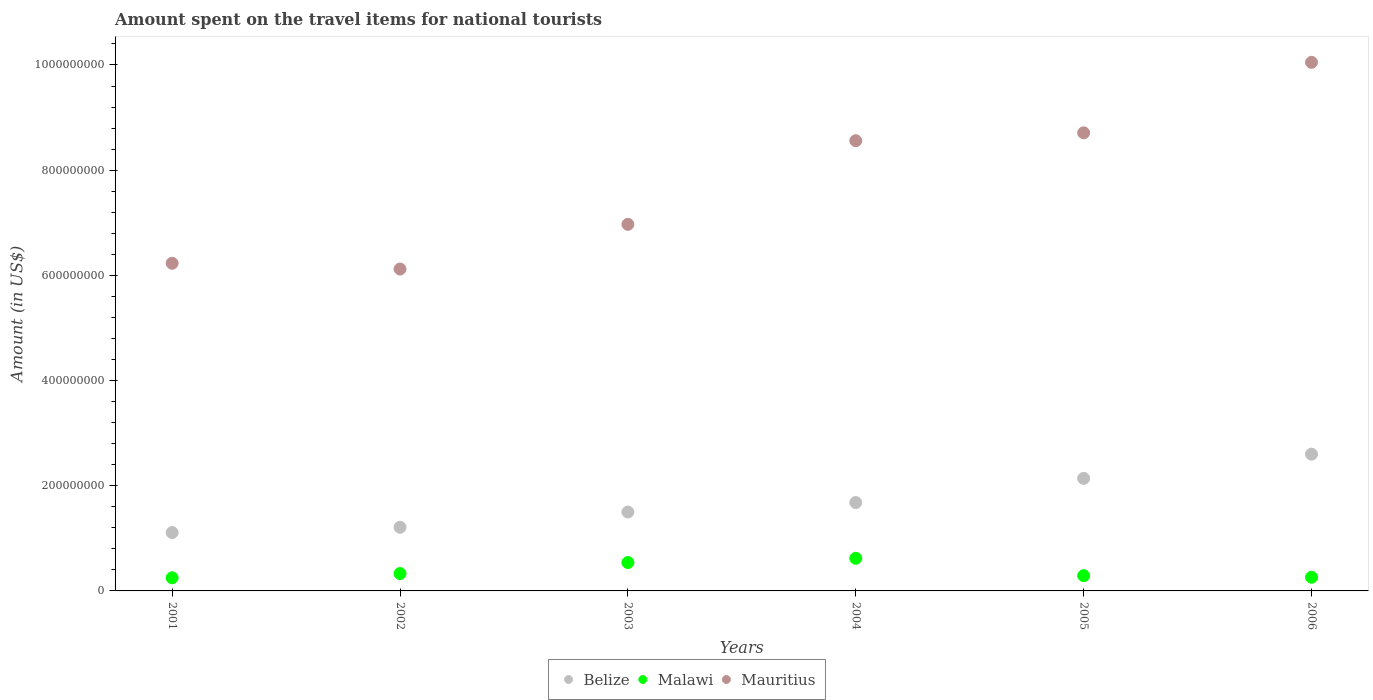Is the number of dotlines equal to the number of legend labels?
Your response must be concise. Yes. What is the amount spent on the travel items for national tourists in Mauritius in 2001?
Your answer should be compact. 6.23e+08. Across all years, what is the maximum amount spent on the travel items for national tourists in Mauritius?
Make the answer very short. 1.00e+09. Across all years, what is the minimum amount spent on the travel items for national tourists in Mauritius?
Your answer should be very brief. 6.12e+08. In which year was the amount spent on the travel items for national tourists in Mauritius maximum?
Offer a very short reply. 2006. What is the total amount spent on the travel items for national tourists in Mauritius in the graph?
Offer a terse response. 4.66e+09. What is the difference between the amount spent on the travel items for national tourists in Malawi in 2001 and that in 2003?
Your answer should be compact. -2.90e+07. What is the difference between the amount spent on the travel items for national tourists in Mauritius in 2004 and the amount spent on the travel items for national tourists in Belize in 2002?
Make the answer very short. 7.35e+08. What is the average amount spent on the travel items for national tourists in Belize per year?
Provide a succinct answer. 1.71e+08. In the year 2004, what is the difference between the amount spent on the travel items for national tourists in Malawi and amount spent on the travel items for national tourists in Belize?
Make the answer very short. -1.06e+08. In how many years, is the amount spent on the travel items for national tourists in Malawi greater than 520000000 US$?
Ensure brevity in your answer.  0. What is the ratio of the amount spent on the travel items for national tourists in Belize in 2001 to that in 2002?
Ensure brevity in your answer.  0.92. Is the amount spent on the travel items for national tourists in Malawi in 2001 less than that in 2002?
Keep it short and to the point. Yes. Is the difference between the amount spent on the travel items for national tourists in Malawi in 2001 and 2005 greater than the difference between the amount spent on the travel items for national tourists in Belize in 2001 and 2005?
Make the answer very short. Yes. What is the difference between the highest and the second highest amount spent on the travel items for national tourists in Belize?
Keep it short and to the point. 4.60e+07. What is the difference between the highest and the lowest amount spent on the travel items for national tourists in Malawi?
Provide a succinct answer. 3.70e+07. In how many years, is the amount spent on the travel items for national tourists in Belize greater than the average amount spent on the travel items for national tourists in Belize taken over all years?
Offer a terse response. 2. Is it the case that in every year, the sum of the amount spent on the travel items for national tourists in Mauritius and amount spent on the travel items for national tourists in Belize  is greater than the amount spent on the travel items for national tourists in Malawi?
Provide a short and direct response. Yes. Is the amount spent on the travel items for national tourists in Malawi strictly greater than the amount spent on the travel items for national tourists in Belize over the years?
Your answer should be compact. No. Is the amount spent on the travel items for national tourists in Belize strictly less than the amount spent on the travel items for national tourists in Mauritius over the years?
Your answer should be very brief. Yes. What is the difference between two consecutive major ticks on the Y-axis?
Ensure brevity in your answer.  2.00e+08. Does the graph contain any zero values?
Your answer should be compact. No. Where does the legend appear in the graph?
Keep it short and to the point. Bottom center. How are the legend labels stacked?
Your response must be concise. Horizontal. What is the title of the graph?
Make the answer very short. Amount spent on the travel items for national tourists. What is the label or title of the Y-axis?
Provide a succinct answer. Amount (in US$). What is the Amount (in US$) of Belize in 2001?
Your response must be concise. 1.11e+08. What is the Amount (in US$) in Malawi in 2001?
Offer a very short reply. 2.50e+07. What is the Amount (in US$) in Mauritius in 2001?
Give a very brief answer. 6.23e+08. What is the Amount (in US$) in Belize in 2002?
Offer a very short reply. 1.21e+08. What is the Amount (in US$) in Malawi in 2002?
Offer a terse response. 3.30e+07. What is the Amount (in US$) of Mauritius in 2002?
Give a very brief answer. 6.12e+08. What is the Amount (in US$) in Belize in 2003?
Ensure brevity in your answer.  1.50e+08. What is the Amount (in US$) in Malawi in 2003?
Your response must be concise. 5.40e+07. What is the Amount (in US$) in Mauritius in 2003?
Your answer should be compact. 6.97e+08. What is the Amount (in US$) in Belize in 2004?
Your answer should be compact. 1.68e+08. What is the Amount (in US$) in Malawi in 2004?
Give a very brief answer. 6.20e+07. What is the Amount (in US$) in Mauritius in 2004?
Your response must be concise. 8.56e+08. What is the Amount (in US$) in Belize in 2005?
Offer a terse response. 2.14e+08. What is the Amount (in US$) in Malawi in 2005?
Offer a terse response. 2.90e+07. What is the Amount (in US$) of Mauritius in 2005?
Provide a short and direct response. 8.71e+08. What is the Amount (in US$) in Belize in 2006?
Keep it short and to the point. 2.60e+08. What is the Amount (in US$) of Malawi in 2006?
Make the answer very short. 2.60e+07. What is the Amount (in US$) of Mauritius in 2006?
Your answer should be compact. 1.00e+09. Across all years, what is the maximum Amount (in US$) in Belize?
Make the answer very short. 2.60e+08. Across all years, what is the maximum Amount (in US$) of Malawi?
Make the answer very short. 6.20e+07. Across all years, what is the maximum Amount (in US$) of Mauritius?
Keep it short and to the point. 1.00e+09. Across all years, what is the minimum Amount (in US$) of Belize?
Ensure brevity in your answer.  1.11e+08. Across all years, what is the minimum Amount (in US$) in Malawi?
Your answer should be very brief. 2.50e+07. Across all years, what is the minimum Amount (in US$) of Mauritius?
Make the answer very short. 6.12e+08. What is the total Amount (in US$) of Belize in the graph?
Your answer should be compact. 1.02e+09. What is the total Amount (in US$) of Malawi in the graph?
Your answer should be compact. 2.29e+08. What is the total Amount (in US$) in Mauritius in the graph?
Offer a very short reply. 4.66e+09. What is the difference between the Amount (in US$) of Belize in 2001 and that in 2002?
Give a very brief answer. -1.00e+07. What is the difference between the Amount (in US$) of Malawi in 2001 and that in 2002?
Provide a succinct answer. -8.00e+06. What is the difference between the Amount (in US$) in Mauritius in 2001 and that in 2002?
Ensure brevity in your answer.  1.10e+07. What is the difference between the Amount (in US$) in Belize in 2001 and that in 2003?
Offer a terse response. -3.90e+07. What is the difference between the Amount (in US$) in Malawi in 2001 and that in 2003?
Your answer should be very brief. -2.90e+07. What is the difference between the Amount (in US$) of Mauritius in 2001 and that in 2003?
Give a very brief answer. -7.40e+07. What is the difference between the Amount (in US$) of Belize in 2001 and that in 2004?
Keep it short and to the point. -5.70e+07. What is the difference between the Amount (in US$) in Malawi in 2001 and that in 2004?
Keep it short and to the point. -3.70e+07. What is the difference between the Amount (in US$) in Mauritius in 2001 and that in 2004?
Make the answer very short. -2.33e+08. What is the difference between the Amount (in US$) in Belize in 2001 and that in 2005?
Your answer should be compact. -1.03e+08. What is the difference between the Amount (in US$) of Mauritius in 2001 and that in 2005?
Keep it short and to the point. -2.48e+08. What is the difference between the Amount (in US$) in Belize in 2001 and that in 2006?
Offer a very short reply. -1.49e+08. What is the difference between the Amount (in US$) in Malawi in 2001 and that in 2006?
Give a very brief answer. -1.00e+06. What is the difference between the Amount (in US$) in Mauritius in 2001 and that in 2006?
Provide a short and direct response. -3.82e+08. What is the difference between the Amount (in US$) in Belize in 2002 and that in 2003?
Offer a terse response. -2.90e+07. What is the difference between the Amount (in US$) in Malawi in 2002 and that in 2003?
Offer a terse response. -2.10e+07. What is the difference between the Amount (in US$) in Mauritius in 2002 and that in 2003?
Keep it short and to the point. -8.50e+07. What is the difference between the Amount (in US$) of Belize in 2002 and that in 2004?
Provide a succinct answer. -4.70e+07. What is the difference between the Amount (in US$) in Malawi in 2002 and that in 2004?
Ensure brevity in your answer.  -2.90e+07. What is the difference between the Amount (in US$) of Mauritius in 2002 and that in 2004?
Offer a very short reply. -2.44e+08. What is the difference between the Amount (in US$) in Belize in 2002 and that in 2005?
Ensure brevity in your answer.  -9.30e+07. What is the difference between the Amount (in US$) of Malawi in 2002 and that in 2005?
Provide a short and direct response. 4.00e+06. What is the difference between the Amount (in US$) in Mauritius in 2002 and that in 2005?
Your response must be concise. -2.59e+08. What is the difference between the Amount (in US$) in Belize in 2002 and that in 2006?
Ensure brevity in your answer.  -1.39e+08. What is the difference between the Amount (in US$) of Malawi in 2002 and that in 2006?
Keep it short and to the point. 7.00e+06. What is the difference between the Amount (in US$) in Mauritius in 2002 and that in 2006?
Your answer should be compact. -3.93e+08. What is the difference between the Amount (in US$) in Belize in 2003 and that in 2004?
Provide a succinct answer. -1.80e+07. What is the difference between the Amount (in US$) of Malawi in 2003 and that in 2004?
Your answer should be compact. -8.00e+06. What is the difference between the Amount (in US$) of Mauritius in 2003 and that in 2004?
Your response must be concise. -1.59e+08. What is the difference between the Amount (in US$) of Belize in 2003 and that in 2005?
Give a very brief answer. -6.40e+07. What is the difference between the Amount (in US$) of Malawi in 2003 and that in 2005?
Your answer should be very brief. 2.50e+07. What is the difference between the Amount (in US$) in Mauritius in 2003 and that in 2005?
Provide a succinct answer. -1.74e+08. What is the difference between the Amount (in US$) of Belize in 2003 and that in 2006?
Give a very brief answer. -1.10e+08. What is the difference between the Amount (in US$) in Malawi in 2003 and that in 2006?
Ensure brevity in your answer.  2.80e+07. What is the difference between the Amount (in US$) of Mauritius in 2003 and that in 2006?
Your answer should be compact. -3.08e+08. What is the difference between the Amount (in US$) of Belize in 2004 and that in 2005?
Provide a short and direct response. -4.60e+07. What is the difference between the Amount (in US$) of Malawi in 2004 and that in 2005?
Your answer should be very brief. 3.30e+07. What is the difference between the Amount (in US$) in Mauritius in 2004 and that in 2005?
Your response must be concise. -1.50e+07. What is the difference between the Amount (in US$) in Belize in 2004 and that in 2006?
Offer a terse response. -9.20e+07. What is the difference between the Amount (in US$) in Malawi in 2004 and that in 2006?
Give a very brief answer. 3.60e+07. What is the difference between the Amount (in US$) in Mauritius in 2004 and that in 2006?
Keep it short and to the point. -1.49e+08. What is the difference between the Amount (in US$) in Belize in 2005 and that in 2006?
Give a very brief answer. -4.60e+07. What is the difference between the Amount (in US$) in Malawi in 2005 and that in 2006?
Offer a very short reply. 3.00e+06. What is the difference between the Amount (in US$) in Mauritius in 2005 and that in 2006?
Offer a very short reply. -1.34e+08. What is the difference between the Amount (in US$) of Belize in 2001 and the Amount (in US$) of Malawi in 2002?
Offer a terse response. 7.80e+07. What is the difference between the Amount (in US$) of Belize in 2001 and the Amount (in US$) of Mauritius in 2002?
Provide a succinct answer. -5.01e+08. What is the difference between the Amount (in US$) in Malawi in 2001 and the Amount (in US$) in Mauritius in 2002?
Provide a succinct answer. -5.87e+08. What is the difference between the Amount (in US$) of Belize in 2001 and the Amount (in US$) of Malawi in 2003?
Give a very brief answer. 5.70e+07. What is the difference between the Amount (in US$) in Belize in 2001 and the Amount (in US$) in Mauritius in 2003?
Offer a very short reply. -5.86e+08. What is the difference between the Amount (in US$) of Malawi in 2001 and the Amount (in US$) of Mauritius in 2003?
Offer a very short reply. -6.72e+08. What is the difference between the Amount (in US$) in Belize in 2001 and the Amount (in US$) in Malawi in 2004?
Give a very brief answer. 4.90e+07. What is the difference between the Amount (in US$) in Belize in 2001 and the Amount (in US$) in Mauritius in 2004?
Your answer should be compact. -7.45e+08. What is the difference between the Amount (in US$) in Malawi in 2001 and the Amount (in US$) in Mauritius in 2004?
Offer a very short reply. -8.31e+08. What is the difference between the Amount (in US$) in Belize in 2001 and the Amount (in US$) in Malawi in 2005?
Ensure brevity in your answer.  8.20e+07. What is the difference between the Amount (in US$) in Belize in 2001 and the Amount (in US$) in Mauritius in 2005?
Keep it short and to the point. -7.60e+08. What is the difference between the Amount (in US$) in Malawi in 2001 and the Amount (in US$) in Mauritius in 2005?
Give a very brief answer. -8.46e+08. What is the difference between the Amount (in US$) of Belize in 2001 and the Amount (in US$) of Malawi in 2006?
Offer a very short reply. 8.50e+07. What is the difference between the Amount (in US$) of Belize in 2001 and the Amount (in US$) of Mauritius in 2006?
Offer a terse response. -8.94e+08. What is the difference between the Amount (in US$) in Malawi in 2001 and the Amount (in US$) in Mauritius in 2006?
Offer a very short reply. -9.80e+08. What is the difference between the Amount (in US$) in Belize in 2002 and the Amount (in US$) in Malawi in 2003?
Give a very brief answer. 6.70e+07. What is the difference between the Amount (in US$) of Belize in 2002 and the Amount (in US$) of Mauritius in 2003?
Ensure brevity in your answer.  -5.76e+08. What is the difference between the Amount (in US$) in Malawi in 2002 and the Amount (in US$) in Mauritius in 2003?
Keep it short and to the point. -6.64e+08. What is the difference between the Amount (in US$) in Belize in 2002 and the Amount (in US$) in Malawi in 2004?
Your answer should be compact. 5.90e+07. What is the difference between the Amount (in US$) of Belize in 2002 and the Amount (in US$) of Mauritius in 2004?
Keep it short and to the point. -7.35e+08. What is the difference between the Amount (in US$) in Malawi in 2002 and the Amount (in US$) in Mauritius in 2004?
Give a very brief answer. -8.23e+08. What is the difference between the Amount (in US$) of Belize in 2002 and the Amount (in US$) of Malawi in 2005?
Ensure brevity in your answer.  9.20e+07. What is the difference between the Amount (in US$) in Belize in 2002 and the Amount (in US$) in Mauritius in 2005?
Provide a succinct answer. -7.50e+08. What is the difference between the Amount (in US$) of Malawi in 2002 and the Amount (in US$) of Mauritius in 2005?
Offer a terse response. -8.38e+08. What is the difference between the Amount (in US$) of Belize in 2002 and the Amount (in US$) of Malawi in 2006?
Offer a very short reply. 9.50e+07. What is the difference between the Amount (in US$) in Belize in 2002 and the Amount (in US$) in Mauritius in 2006?
Your answer should be very brief. -8.84e+08. What is the difference between the Amount (in US$) of Malawi in 2002 and the Amount (in US$) of Mauritius in 2006?
Give a very brief answer. -9.72e+08. What is the difference between the Amount (in US$) of Belize in 2003 and the Amount (in US$) of Malawi in 2004?
Provide a short and direct response. 8.80e+07. What is the difference between the Amount (in US$) of Belize in 2003 and the Amount (in US$) of Mauritius in 2004?
Your answer should be very brief. -7.06e+08. What is the difference between the Amount (in US$) of Malawi in 2003 and the Amount (in US$) of Mauritius in 2004?
Provide a short and direct response. -8.02e+08. What is the difference between the Amount (in US$) of Belize in 2003 and the Amount (in US$) of Malawi in 2005?
Provide a short and direct response. 1.21e+08. What is the difference between the Amount (in US$) of Belize in 2003 and the Amount (in US$) of Mauritius in 2005?
Your answer should be compact. -7.21e+08. What is the difference between the Amount (in US$) of Malawi in 2003 and the Amount (in US$) of Mauritius in 2005?
Give a very brief answer. -8.17e+08. What is the difference between the Amount (in US$) of Belize in 2003 and the Amount (in US$) of Malawi in 2006?
Provide a succinct answer. 1.24e+08. What is the difference between the Amount (in US$) of Belize in 2003 and the Amount (in US$) of Mauritius in 2006?
Your answer should be compact. -8.55e+08. What is the difference between the Amount (in US$) of Malawi in 2003 and the Amount (in US$) of Mauritius in 2006?
Offer a very short reply. -9.51e+08. What is the difference between the Amount (in US$) of Belize in 2004 and the Amount (in US$) of Malawi in 2005?
Provide a short and direct response. 1.39e+08. What is the difference between the Amount (in US$) in Belize in 2004 and the Amount (in US$) in Mauritius in 2005?
Offer a terse response. -7.03e+08. What is the difference between the Amount (in US$) of Malawi in 2004 and the Amount (in US$) of Mauritius in 2005?
Provide a short and direct response. -8.09e+08. What is the difference between the Amount (in US$) of Belize in 2004 and the Amount (in US$) of Malawi in 2006?
Ensure brevity in your answer.  1.42e+08. What is the difference between the Amount (in US$) in Belize in 2004 and the Amount (in US$) in Mauritius in 2006?
Provide a short and direct response. -8.37e+08. What is the difference between the Amount (in US$) of Malawi in 2004 and the Amount (in US$) of Mauritius in 2006?
Provide a succinct answer. -9.43e+08. What is the difference between the Amount (in US$) of Belize in 2005 and the Amount (in US$) of Malawi in 2006?
Offer a very short reply. 1.88e+08. What is the difference between the Amount (in US$) in Belize in 2005 and the Amount (in US$) in Mauritius in 2006?
Offer a very short reply. -7.91e+08. What is the difference between the Amount (in US$) of Malawi in 2005 and the Amount (in US$) of Mauritius in 2006?
Make the answer very short. -9.76e+08. What is the average Amount (in US$) in Belize per year?
Ensure brevity in your answer.  1.71e+08. What is the average Amount (in US$) of Malawi per year?
Provide a short and direct response. 3.82e+07. What is the average Amount (in US$) of Mauritius per year?
Keep it short and to the point. 7.77e+08. In the year 2001, what is the difference between the Amount (in US$) of Belize and Amount (in US$) of Malawi?
Give a very brief answer. 8.60e+07. In the year 2001, what is the difference between the Amount (in US$) in Belize and Amount (in US$) in Mauritius?
Your answer should be compact. -5.12e+08. In the year 2001, what is the difference between the Amount (in US$) of Malawi and Amount (in US$) of Mauritius?
Provide a short and direct response. -5.98e+08. In the year 2002, what is the difference between the Amount (in US$) of Belize and Amount (in US$) of Malawi?
Your answer should be compact. 8.80e+07. In the year 2002, what is the difference between the Amount (in US$) of Belize and Amount (in US$) of Mauritius?
Provide a succinct answer. -4.91e+08. In the year 2002, what is the difference between the Amount (in US$) of Malawi and Amount (in US$) of Mauritius?
Ensure brevity in your answer.  -5.79e+08. In the year 2003, what is the difference between the Amount (in US$) in Belize and Amount (in US$) in Malawi?
Make the answer very short. 9.60e+07. In the year 2003, what is the difference between the Amount (in US$) of Belize and Amount (in US$) of Mauritius?
Keep it short and to the point. -5.47e+08. In the year 2003, what is the difference between the Amount (in US$) of Malawi and Amount (in US$) of Mauritius?
Offer a terse response. -6.43e+08. In the year 2004, what is the difference between the Amount (in US$) of Belize and Amount (in US$) of Malawi?
Offer a terse response. 1.06e+08. In the year 2004, what is the difference between the Amount (in US$) in Belize and Amount (in US$) in Mauritius?
Offer a very short reply. -6.88e+08. In the year 2004, what is the difference between the Amount (in US$) of Malawi and Amount (in US$) of Mauritius?
Keep it short and to the point. -7.94e+08. In the year 2005, what is the difference between the Amount (in US$) in Belize and Amount (in US$) in Malawi?
Your answer should be compact. 1.85e+08. In the year 2005, what is the difference between the Amount (in US$) of Belize and Amount (in US$) of Mauritius?
Your answer should be compact. -6.57e+08. In the year 2005, what is the difference between the Amount (in US$) in Malawi and Amount (in US$) in Mauritius?
Ensure brevity in your answer.  -8.42e+08. In the year 2006, what is the difference between the Amount (in US$) of Belize and Amount (in US$) of Malawi?
Your answer should be compact. 2.34e+08. In the year 2006, what is the difference between the Amount (in US$) of Belize and Amount (in US$) of Mauritius?
Offer a very short reply. -7.45e+08. In the year 2006, what is the difference between the Amount (in US$) in Malawi and Amount (in US$) in Mauritius?
Ensure brevity in your answer.  -9.79e+08. What is the ratio of the Amount (in US$) in Belize in 2001 to that in 2002?
Ensure brevity in your answer.  0.92. What is the ratio of the Amount (in US$) of Malawi in 2001 to that in 2002?
Ensure brevity in your answer.  0.76. What is the ratio of the Amount (in US$) in Belize in 2001 to that in 2003?
Keep it short and to the point. 0.74. What is the ratio of the Amount (in US$) in Malawi in 2001 to that in 2003?
Offer a very short reply. 0.46. What is the ratio of the Amount (in US$) in Mauritius in 2001 to that in 2003?
Provide a short and direct response. 0.89. What is the ratio of the Amount (in US$) of Belize in 2001 to that in 2004?
Give a very brief answer. 0.66. What is the ratio of the Amount (in US$) in Malawi in 2001 to that in 2004?
Provide a short and direct response. 0.4. What is the ratio of the Amount (in US$) of Mauritius in 2001 to that in 2004?
Keep it short and to the point. 0.73. What is the ratio of the Amount (in US$) of Belize in 2001 to that in 2005?
Provide a succinct answer. 0.52. What is the ratio of the Amount (in US$) of Malawi in 2001 to that in 2005?
Provide a succinct answer. 0.86. What is the ratio of the Amount (in US$) in Mauritius in 2001 to that in 2005?
Offer a terse response. 0.72. What is the ratio of the Amount (in US$) in Belize in 2001 to that in 2006?
Your response must be concise. 0.43. What is the ratio of the Amount (in US$) of Malawi in 2001 to that in 2006?
Your answer should be compact. 0.96. What is the ratio of the Amount (in US$) in Mauritius in 2001 to that in 2006?
Your answer should be compact. 0.62. What is the ratio of the Amount (in US$) in Belize in 2002 to that in 2003?
Provide a short and direct response. 0.81. What is the ratio of the Amount (in US$) in Malawi in 2002 to that in 2003?
Ensure brevity in your answer.  0.61. What is the ratio of the Amount (in US$) in Mauritius in 2002 to that in 2003?
Your answer should be compact. 0.88. What is the ratio of the Amount (in US$) in Belize in 2002 to that in 2004?
Your answer should be compact. 0.72. What is the ratio of the Amount (in US$) in Malawi in 2002 to that in 2004?
Give a very brief answer. 0.53. What is the ratio of the Amount (in US$) of Mauritius in 2002 to that in 2004?
Offer a very short reply. 0.71. What is the ratio of the Amount (in US$) of Belize in 2002 to that in 2005?
Your answer should be compact. 0.57. What is the ratio of the Amount (in US$) of Malawi in 2002 to that in 2005?
Your answer should be very brief. 1.14. What is the ratio of the Amount (in US$) of Mauritius in 2002 to that in 2005?
Your answer should be very brief. 0.7. What is the ratio of the Amount (in US$) of Belize in 2002 to that in 2006?
Ensure brevity in your answer.  0.47. What is the ratio of the Amount (in US$) in Malawi in 2002 to that in 2006?
Your response must be concise. 1.27. What is the ratio of the Amount (in US$) in Mauritius in 2002 to that in 2006?
Offer a terse response. 0.61. What is the ratio of the Amount (in US$) in Belize in 2003 to that in 2004?
Your answer should be compact. 0.89. What is the ratio of the Amount (in US$) of Malawi in 2003 to that in 2004?
Offer a terse response. 0.87. What is the ratio of the Amount (in US$) in Mauritius in 2003 to that in 2004?
Offer a terse response. 0.81. What is the ratio of the Amount (in US$) of Belize in 2003 to that in 2005?
Your response must be concise. 0.7. What is the ratio of the Amount (in US$) of Malawi in 2003 to that in 2005?
Offer a very short reply. 1.86. What is the ratio of the Amount (in US$) of Mauritius in 2003 to that in 2005?
Offer a very short reply. 0.8. What is the ratio of the Amount (in US$) of Belize in 2003 to that in 2006?
Your response must be concise. 0.58. What is the ratio of the Amount (in US$) in Malawi in 2003 to that in 2006?
Provide a succinct answer. 2.08. What is the ratio of the Amount (in US$) in Mauritius in 2003 to that in 2006?
Ensure brevity in your answer.  0.69. What is the ratio of the Amount (in US$) in Belize in 2004 to that in 2005?
Offer a very short reply. 0.79. What is the ratio of the Amount (in US$) of Malawi in 2004 to that in 2005?
Your answer should be very brief. 2.14. What is the ratio of the Amount (in US$) of Mauritius in 2004 to that in 2005?
Make the answer very short. 0.98. What is the ratio of the Amount (in US$) of Belize in 2004 to that in 2006?
Provide a short and direct response. 0.65. What is the ratio of the Amount (in US$) in Malawi in 2004 to that in 2006?
Your answer should be compact. 2.38. What is the ratio of the Amount (in US$) of Mauritius in 2004 to that in 2006?
Offer a terse response. 0.85. What is the ratio of the Amount (in US$) of Belize in 2005 to that in 2006?
Your answer should be very brief. 0.82. What is the ratio of the Amount (in US$) of Malawi in 2005 to that in 2006?
Your response must be concise. 1.12. What is the ratio of the Amount (in US$) in Mauritius in 2005 to that in 2006?
Keep it short and to the point. 0.87. What is the difference between the highest and the second highest Amount (in US$) of Belize?
Give a very brief answer. 4.60e+07. What is the difference between the highest and the second highest Amount (in US$) of Malawi?
Ensure brevity in your answer.  8.00e+06. What is the difference between the highest and the second highest Amount (in US$) of Mauritius?
Provide a succinct answer. 1.34e+08. What is the difference between the highest and the lowest Amount (in US$) of Belize?
Make the answer very short. 1.49e+08. What is the difference between the highest and the lowest Amount (in US$) of Malawi?
Offer a terse response. 3.70e+07. What is the difference between the highest and the lowest Amount (in US$) of Mauritius?
Make the answer very short. 3.93e+08. 